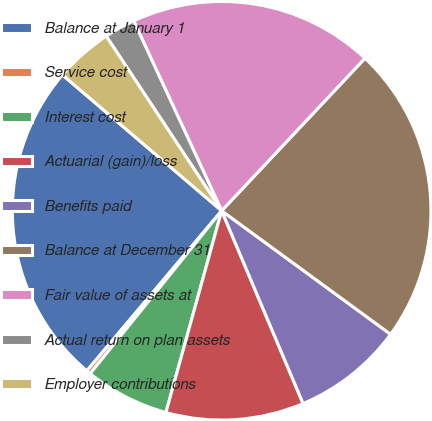Convert chart to OTSL. <chart><loc_0><loc_0><loc_500><loc_500><pie_chart><fcel>Balance at January 1<fcel>Service cost<fcel>Interest cost<fcel>Actuarial (gain)/loss<fcel>Benefits paid<fcel>Balance at December 31<fcel>Fair value of assets at<fcel>Actual return on plan assets<fcel>Employer contributions<nl><fcel>25.1%<fcel>0.33%<fcel>6.52%<fcel>10.65%<fcel>8.59%<fcel>23.04%<fcel>18.91%<fcel>2.39%<fcel>4.46%<nl></chart> 